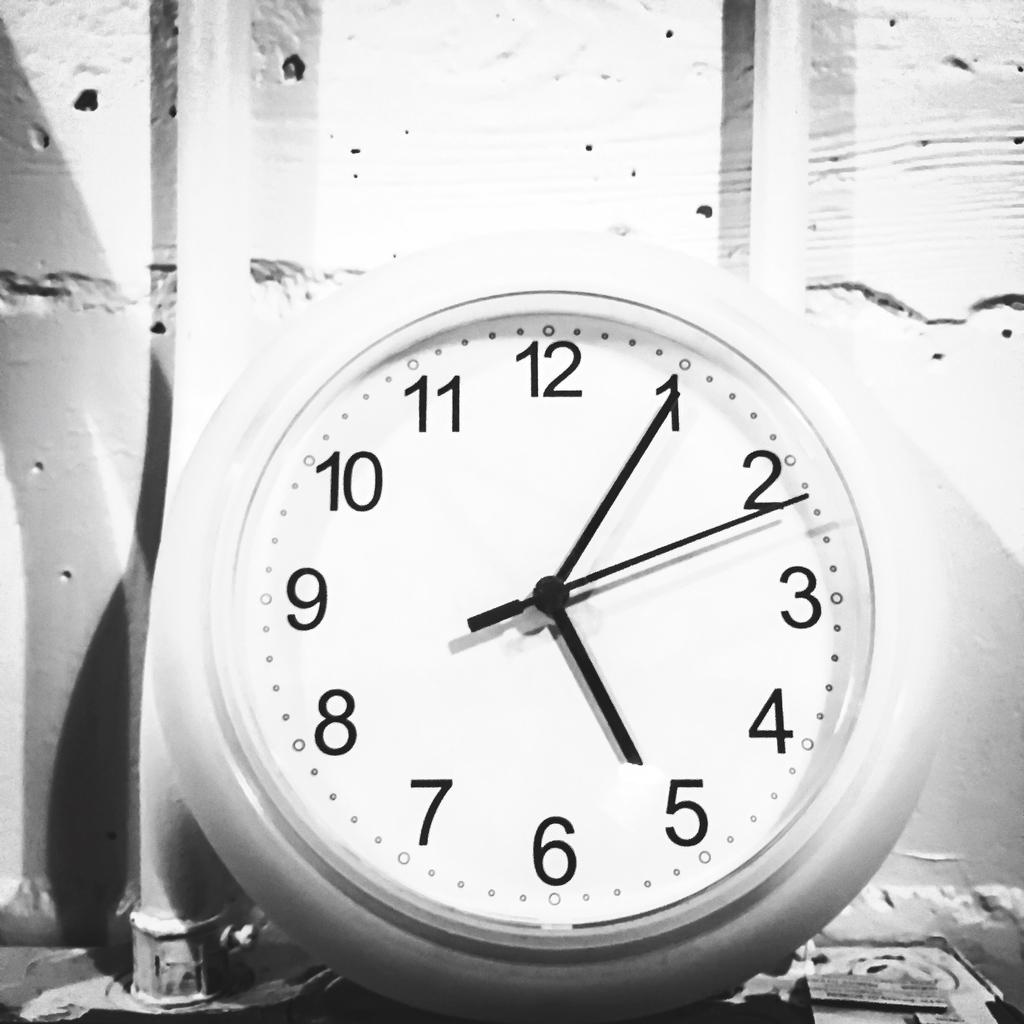What time is it?
Your answer should be very brief. 5:05. What number is the bottom number?
Provide a short and direct response. 6. 